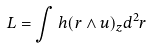<formula> <loc_0><loc_0><loc_500><loc_500>L = \int h ( r \wedge u ) _ { z } d ^ { 2 } r</formula> 